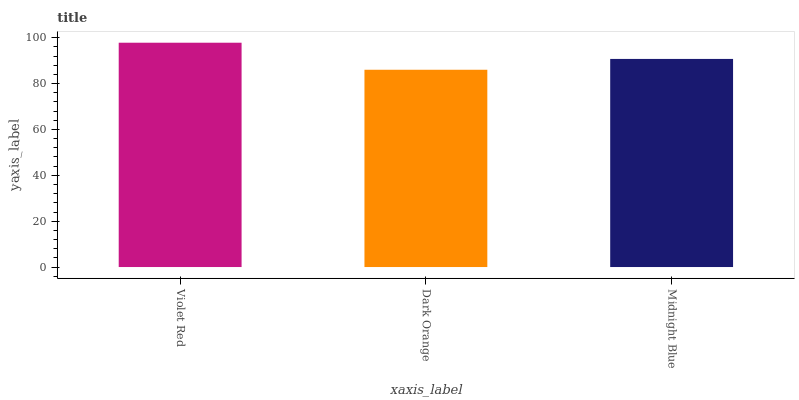Is Midnight Blue the minimum?
Answer yes or no. No. Is Midnight Blue the maximum?
Answer yes or no. No. Is Midnight Blue greater than Dark Orange?
Answer yes or no. Yes. Is Dark Orange less than Midnight Blue?
Answer yes or no. Yes. Is Dark Orange greater than Midnight Blue?
Answer yes or no. No. Is Midnight Blue less than Dark Orange?
Answer yes or no. No. Is Midnight Blue the high median?
Answer yes or no. Yes. Is Midnight Blue the low median?
Answer yes or no. Yes. Is Violet Red the high median?
Answer yes or no. No. Is Violet Red the low median?
Answer yes or no. No. 